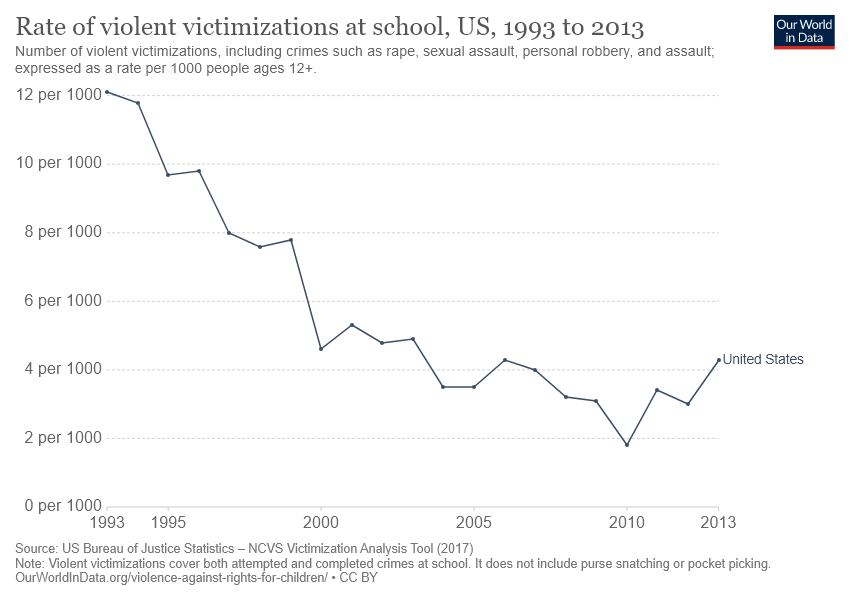List a handful of essential elements in this visual. The highest value was achieved in 1993. The task is to compare the year 1993 with the year 2010 based on their respective values. 